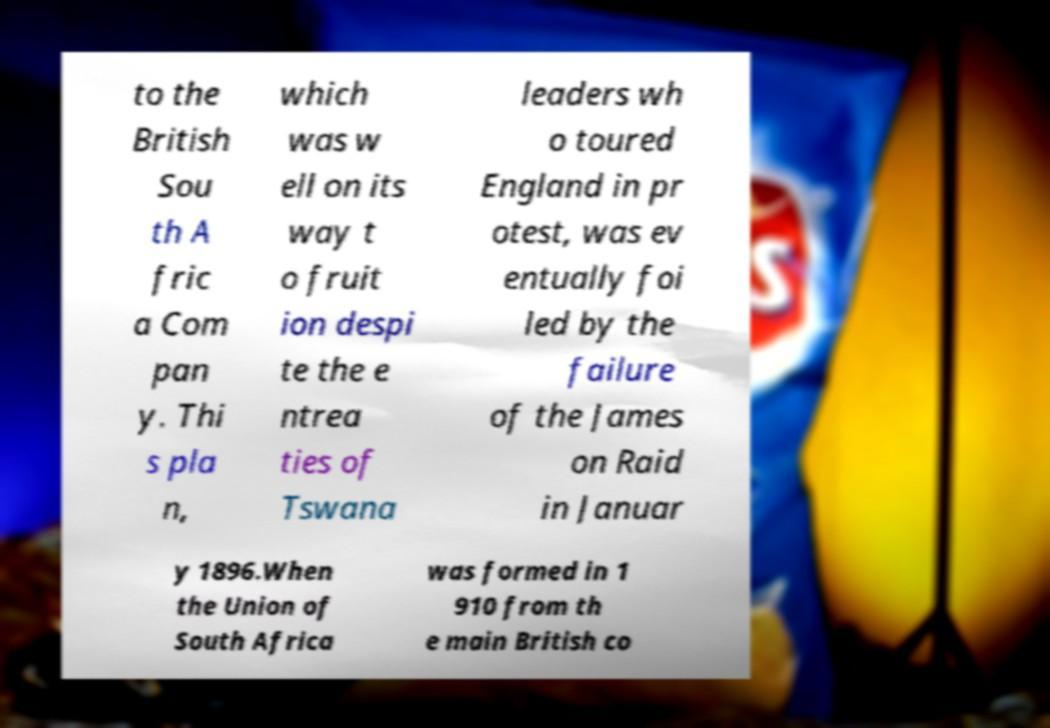Could you assist in decoding the text presented in this image and type it out clearly? to the British Sou th A fric a Com pan y. Thi s pla n, which was w ell on its way t o fruit ion despi te the e ntrea ties of Tswana leaders wh o toured England in pr otest, was ev entually foi led by the failure of the James on Raid in Januar y 1896.When the Union of South Africa was formed in 1 910 from th e main British co 